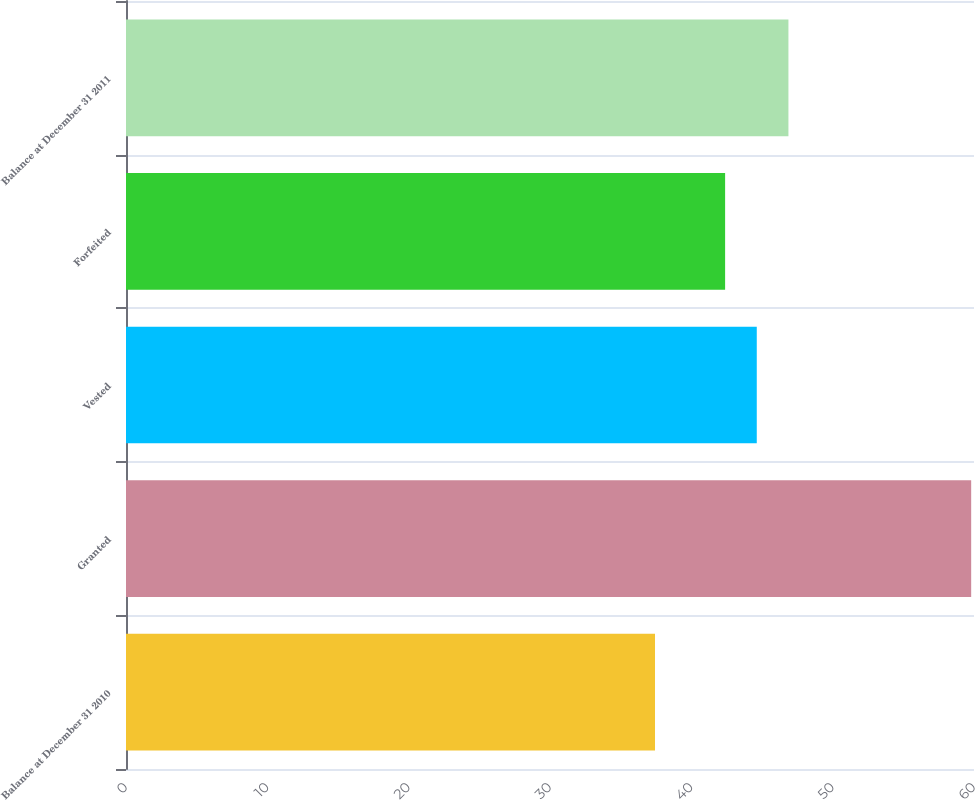Convert chart to OTSL. <chart><loc_0><loc_0><loc_500><loc_500><bar_chart><fcel>Balance at December 31 2010<fcel>Granted<fcel>Vested<fcel>Forfeited<fcel>Balance at December 31 2011<nl><fcel>37.43<fcel>59.8<fcel>44.63<fcel>42.39<fcel>46.87<nl></chart> 